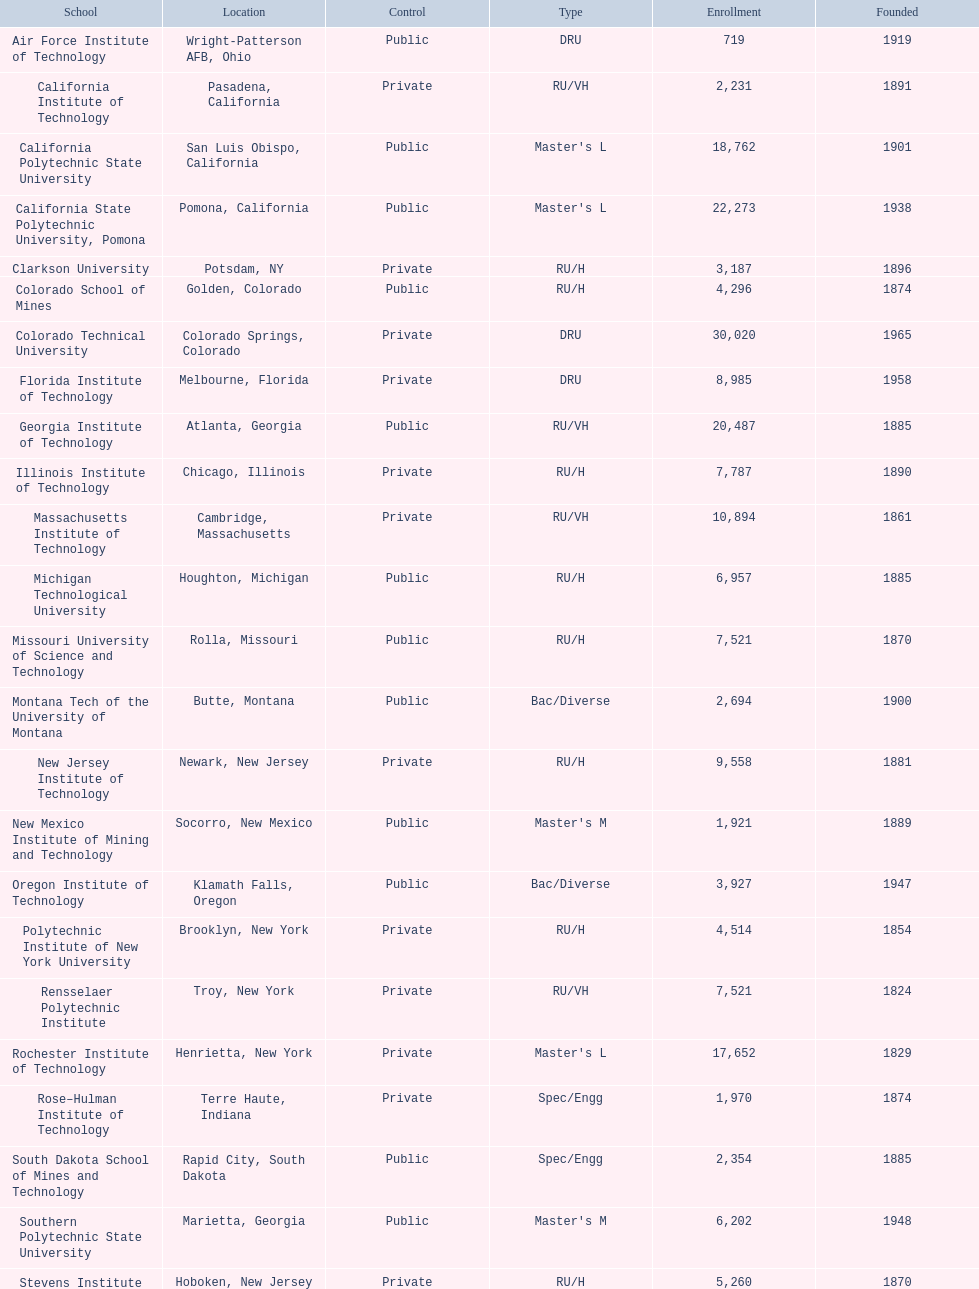Which school had the largest enrollment? Texas Tech University. 